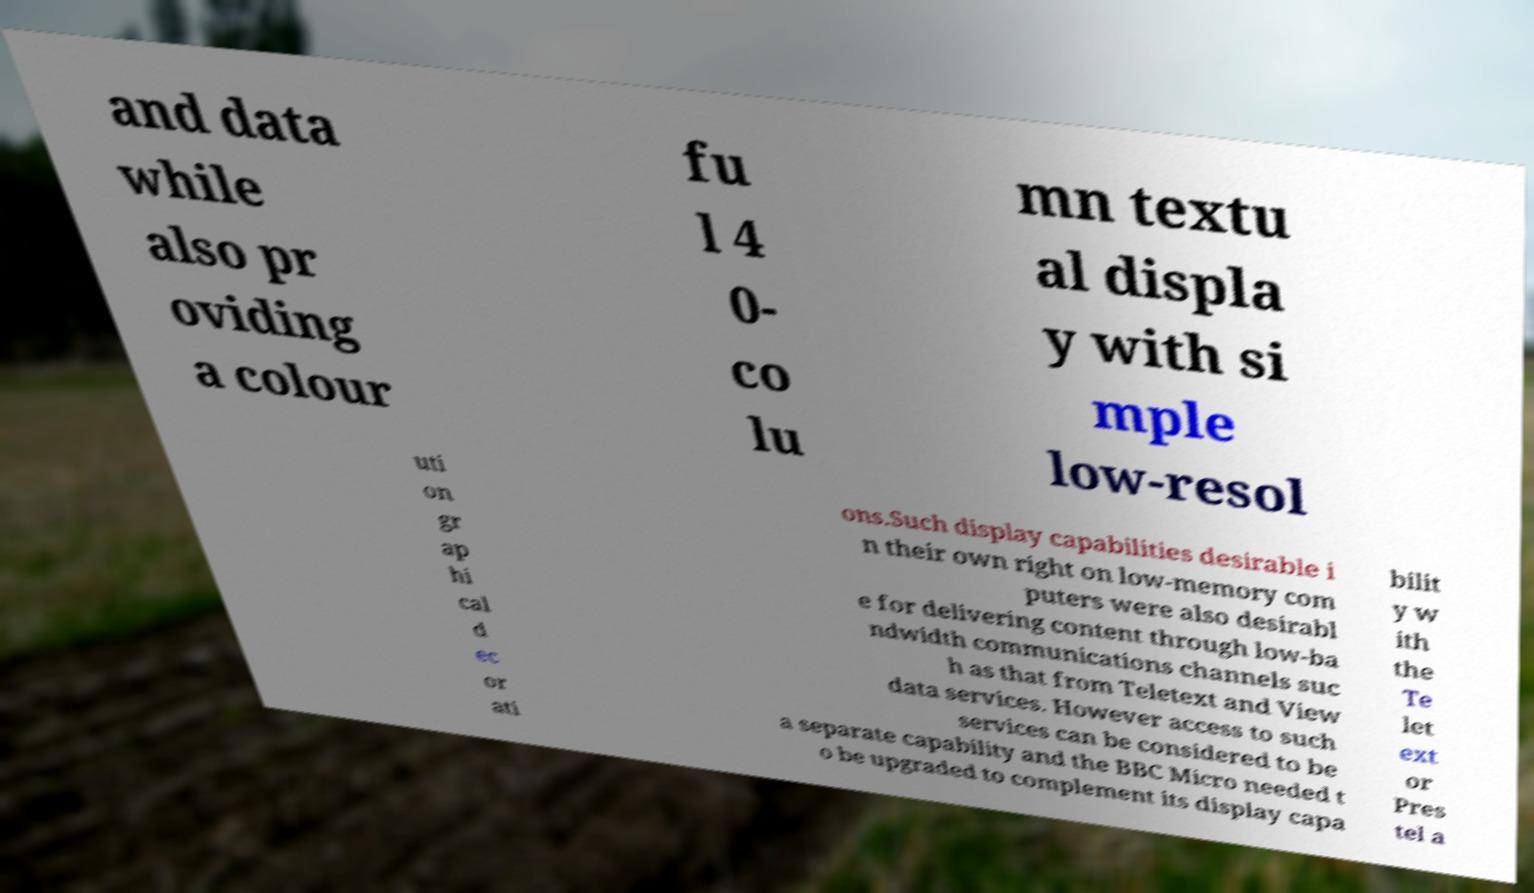Please identify and transcribe the text found in this image. and data while also pr oviding a colour fu l 4 0- co lu mn textu al displa y with si mple low-resol uti on gr ap hi cal d ec or ati ons.Such display capabilities desirable i n their own right on low-memory com puters were also desirabl e for delivering content through low-ba ndwidth communications channels suc h as that from Teletext and View data services. However access to such services can be considered to be a separate capability and the BBC Micro needed t o be upgraded to complement its display capa bilit y w ith the Te let ext or Pres tel a 